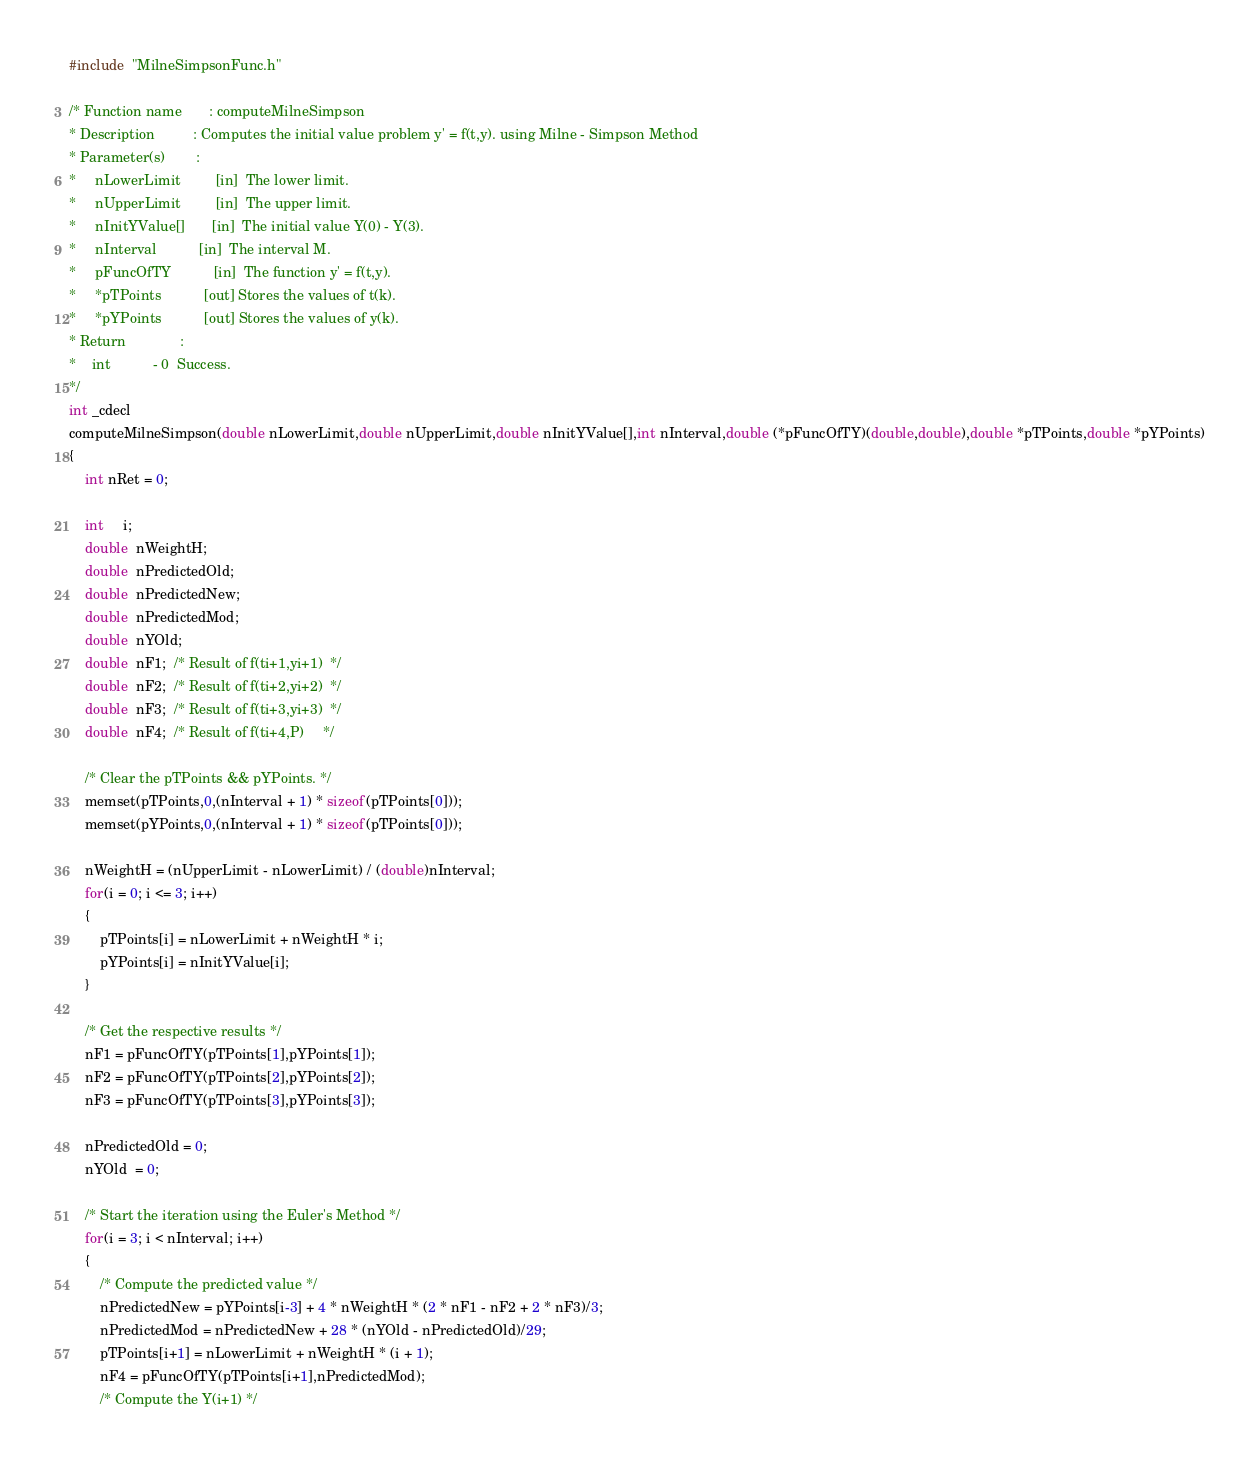Convert code to text. <code><loc_0><loc_0><loc_500><loc_500><_C_>#include  "MilneSimpsonFunc.h"

/* Function name       : computeMilneSimpson
* Description          : Computes the initial value problem y' = f(t,y). using Milne - Simpson Method
* Parameter(s)        : 
*     nLowerLimit         [in]  The lower limit.
*     nUpperLimit         [in]  The upper limit.
*     nInitYValue[]       [in]  The initial value Y(0) - Y(3).
*     nInterval           [in]  The interval M.
*     pFuncOfTY           [in]  The function y' = f(t,y).
*     *pTPoints           [out] Stores the values of t(k).
*     *pYPoints           [out] Stores the values of y(k).
* Return              :     
*    int           - 0  Success. 
*/
int _cdecl 
computeMilneSimpson(double nLowerLimit,double nUpperLimit,double nInitYValue[],int nInterval,double (*pFuncOfTY)(double,double),double *pTPoints,double *pYPoints)
{
    int nRet = 0;
   
    int     i;
    double  nWeightH;
    double  nPredictedOld;
    double  nPredictedNew;
    double  nPredictedMod;
    double  nYOld;
    double  nF1;  /* Result of f(ti+1,yi+1)  */
    double  nF2;  /* Result of f(ti+2,yi+2)  */
    double  nF3;  /* Result of f(ti+3,yi+3)  */
    double  nF4;  /* Result of f(ti+4,P)     */

    /* Clear the pTPoints && pYPoints. */
    memset(pTPoints,0,(nInterval + 1) * sizeof(pTPoints[0]));
    memset(pYPoints,0,(nInterval + 1) * sizeof(pTPoints[0]));

    nWeightH = (nUpperLimit - nLowerLimit) / (double)nInterval;
    for(i = 0; i <= 3; i++)
    {
        pTPoints[i] = nLowerLimit + nWeightH * i;
        pYPoints[i] = nInitYValue[i];
    }

    /* Get the respective results */
    nF1 = pFuncOfTY(pTPoints[1],pYPoints[1]);
    nF2 = pFuncOfTY(pTPoints[2],pYPoints[2]);
    nF3 = pFuncOfTY(pTPoints[3],pYPoints[3]);

    nPredictedOld = 0;
    nYOld  = 0;

    /* Start the iteration using the Euler's Method */
    for(i = 3; i < nInterval; i++)
    {
        /* Compute the predicted value */
        nPredictedNew = pYPoints[i-3] + 4 * nWeightH * (2 * nF1 - nF2 + 2 * nF3)/3;
        nPredictedMod = nPredictedNew + 28 * (nYOld - nPredictedOld)/29;
        pTPoints[i+1] = nLowerLimit + nWeightH * (i + 1);
        nF4 = pFuncOfTY(pTPoints[i+1],nPredictedMod);
        /* Compute the Y(i+1) */</code> 